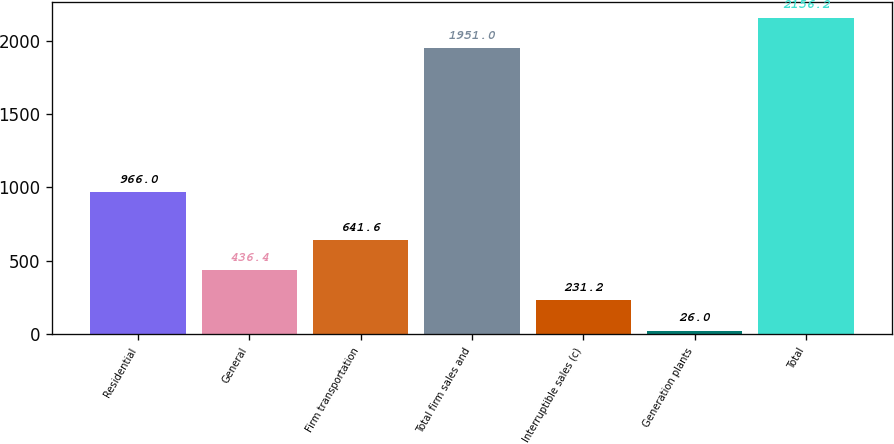<chart> <loc_0><loc_0><loc_500><loc_500><bar_chart><fcel>Residential<fcel>General<fcel>Firm transportation<fcel>Total firm sales and<fcel>Interruptible sales (c)<fcel>Generation plants<fcel>Total<nl><fcel>966<fcel>436.4<fcel>641.6<fcel>1951<fcel>231.2<fcel>26<fcel>2156.2<nl></chart> 